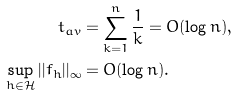Convert formula to latex. <formula><loc_0><loc_0><loc_500><loc_500>t _ { a v } & = \sum _ { k = 1 } ^ { n } \frac { 1 } { k } = O ( \log n ) , \\ \sup _ { h \in \mathcal { H } } | | f _ { h } | | _ { \infty } & = O ( \log n ) .</formula> 